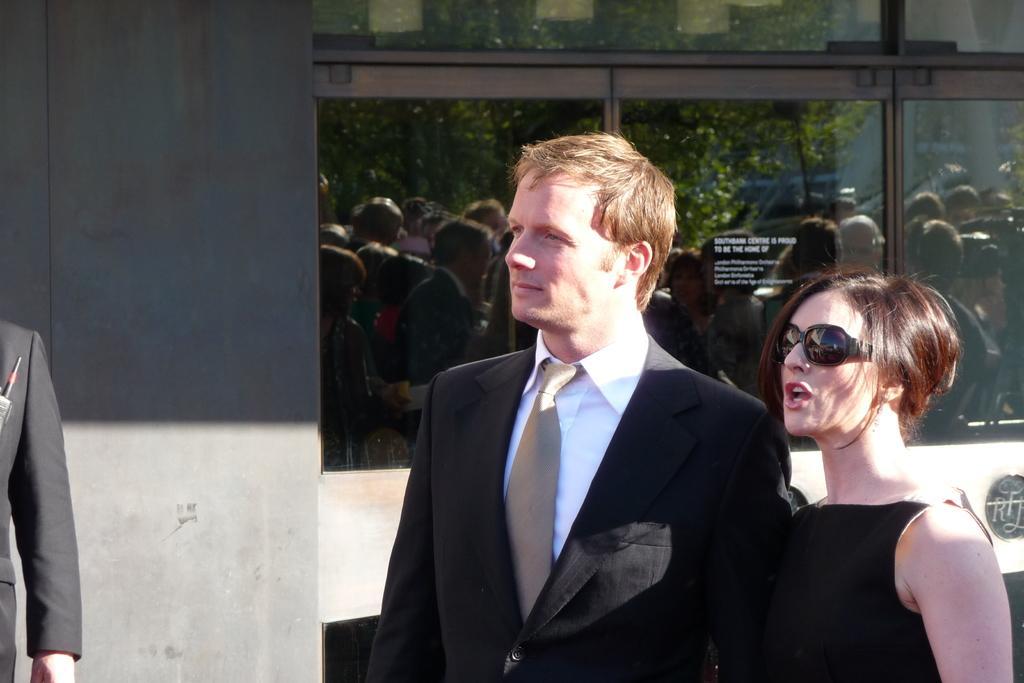How would you summarize this image in a sentence or two? In this image, we can see a woman and man. Here we can see a woman wearing a goggles. Background there is a wall, glass windows. Left side of the image, we can see a human hand and some object. On the glass, we can see a group of people are reflecting. Here we can see a tree. 